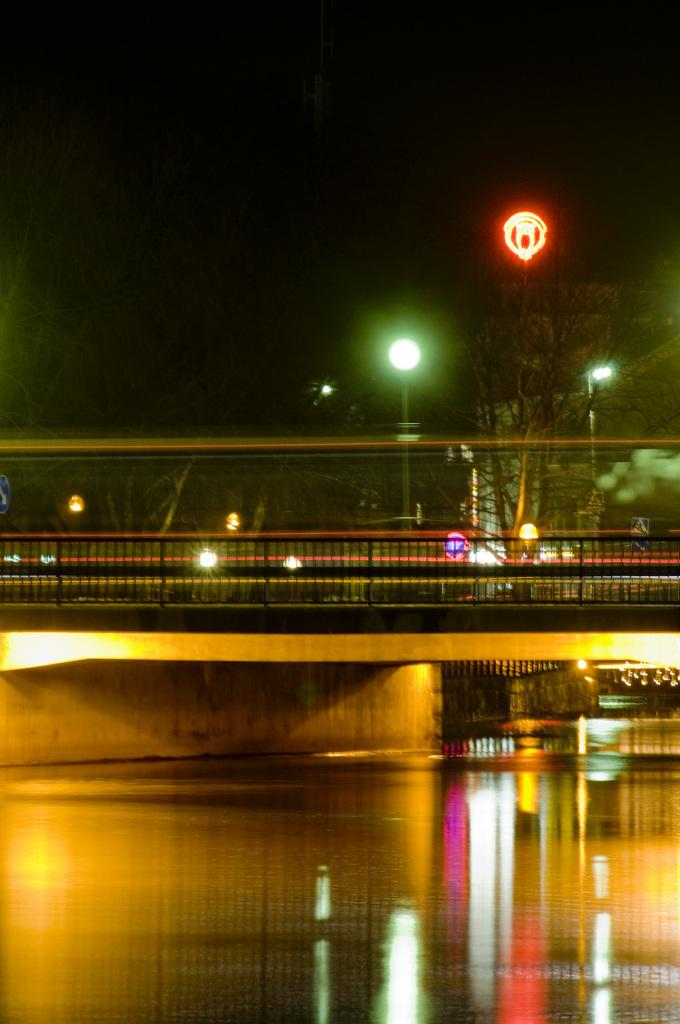What structure is present in the image that allows people or vehicles to cross over something? There is a bridge in the image that allows people or vehicles to cross over something. What can be seen beneath the bridge? There is water beneath the bridge. What type of vegetation is visible on the other side of the bridge? There are trees on the other side of the bridge. What lighting feature is present in the image? There are lamp posts in the image. How many goats are grazing on the flowers near the trucks in the image? There are no goats, flowers, or trucks present in the image. 